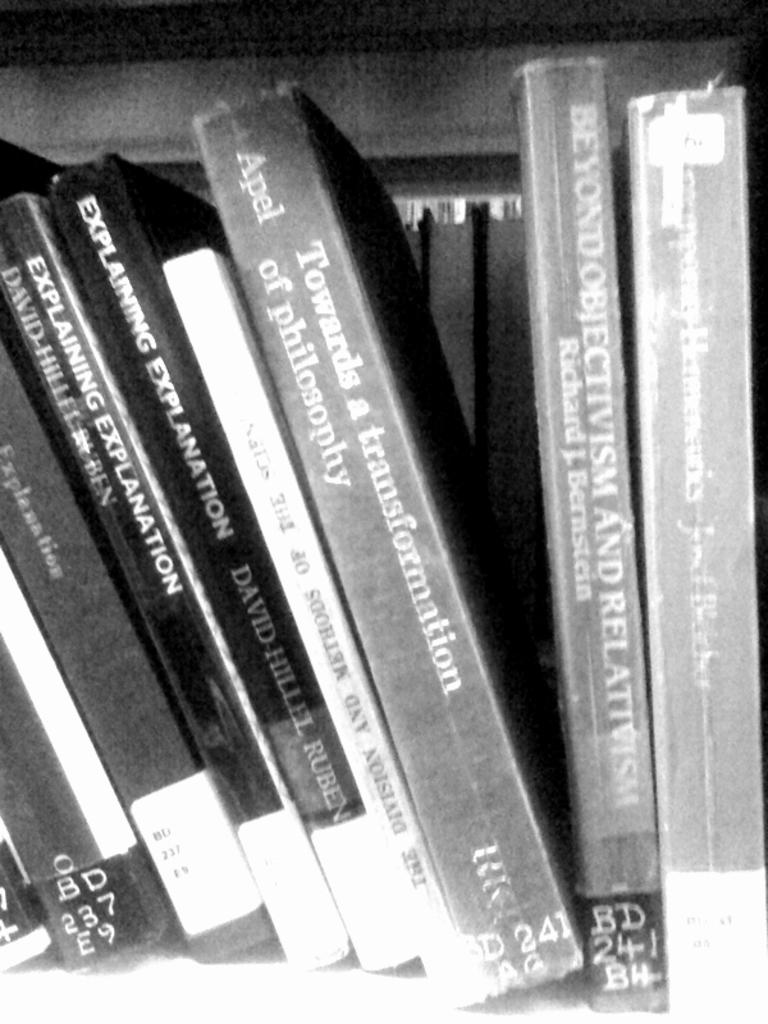<image>
Provide a brief description of the given image. A book shelf has philosophy books such as Explaining Explanation. 